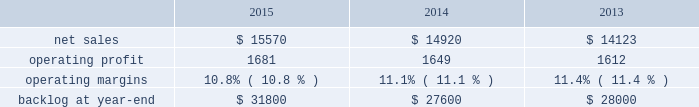Aeronautics our aeronautics business segment is engaged in the research , design , development , manufacture , integration , sustainment , support and upgrade of advanced military aircraft , including combat and air mobility aircraft , unmanned air vehicles and related technologies .
Aeronautics 2019 major programs include the f-35 lightning ii joint strike fighter , c-130 hercules , f-16 fighting falcon , c-5m super galaxy and f-22 raptor .
Aeronautics 2019 operating results included the following ( in millions ) : .
2015 compared to 2014 aeronautics 2019 net sales in 2015 increased $ 650 million , or 4% ( 4 % ) , compared to 2014 .
The increase was attributable to higher net sales of approximately $ 1.4 billion for f-35 production contracts due to increased volume on aircraft production and sustainment activities ; and approximately $ 150 million for the c-5 program due to increased deliveries ( nine aircraft delivered in 2015 compared to seven delivered in 2014 ) .
The increases were partially offset by lower net sales of approximately $ 350 million for the c-130 program due to fewer aircraft deliveries ( 21 aircraft delivered in 2015 , compared to 24 delivered in 2014 ) , lower sustainment activities and aircraft contract mix ; approximately $ 200 million due to decreased volume and lower risk retirements on various programs ; approximately $ 195 million for the f-16 program due to fewer deliveries ( 11 aircraft delivered in 2015 , compared to 17 delivered in 2014 ) ; and approximately $ 190 million for the f-22 program as a result of decreased sustainment activities .
Aeronautics 2019 operating profit in 2015 increased $ 32 million , or 2% ( 2 % ) , compared to 2014 .
Operating profit increased by approximately $ 240 million for f-35 production contracts due to increased volume and risk retirements ; and approximately $ 40 million for the c-5 program due to increased risk retirements .
These increases were offset by lower operating profit of approximately $ 90 million for the f-22 program due to lower risk retirements ; approximately $ 70 million for the c-130 program as a result of the reasons stated above for lower net sales ; and approximately $ 80 million due to decreased volume and risk retirements on various programs .
Adjustments not related to volume , including net profit booking rate adjustments and other matters , were approximately $ 100 million higher in 2015 compared to 2014 .
2014 compared to 2013 aeronautics 2019 net sales increased $ 797 million , or 6% ( 6 % ) , in 2014 as compared to 2013 .
The increase was primarily attributable to higher net sales of approximately $ 790 million for f-35 production contracts due to increased volume and sustainment activities ; about $ 55 million for the f-16 program due to increased deliveries ( 17 aircraft delivered in 2014 compared to 13 delivered in 2013 ) partially offset by contract mix ; and approximately $ 45 million for the f-22 program due to increased risk retirements .
The increases were partially offset by lower net sales of approximately $ 55 million for the f-35 development contract due to decreased volume , partially offset by the absence in 2014 of the downward revision to the profit booking rate that occurred in 2013 ; and about $ 40 million for the c-130 program due to fewer deliveries ( 24 aircraft delivered in 2014 compared to 25 delivered in 2013 ) and decreased sustainment activities , partially offset by contract mix .
Aeronautics 2019 operating profit increased $ 37 million , or 2% ( 2 % ) , in 2014 as compared to 2013 .
The increase was primarily attributable to higher operating profit of approximately $ 85 million for the f-35 development contract due to the absence in 2014 of the downward revision to the profit booking rate that occurred in 2013 ; about $ 75 million for the f-22 program due to increased risk retirements ; approximately $ 50 million for the c-130 program due to increased risk retirements and contract mix , partially offset by fewer deliveries ; and about $ 25 million for the c-5 program due to the absence in 2014 of the downward revisions to the profit booking rate that occurred in 2013 .
The increases were partially offset by lower operating profit of approximately $ 130 million for the f-16 program due to decreased risk retirements , partially offset by increased deliveries ; and about $ 70 million for sustainment activities due to decreased risk retirements and volume .
Operating profit was comparable for f-35 production contracts as higher volume was offset by lower risk retirements .
Adjustments not related to volume , including net profit booking rate adjustments and other matters , were approximately $ 105 million lower for 2014 compared to 2013. .
What was the average backlog at year-end in millions from 2013 to 2015? 
Computations: (((31800 + 27600) + 28000) / 3)
Answer: 29133.33333. 